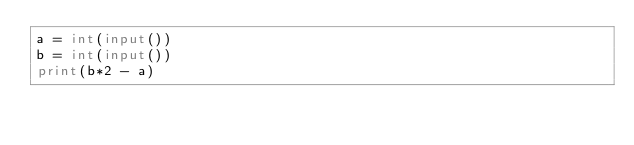Convert code to text. <code><loc_0><loc_0><loc_500><loc_500><_Python_>a = int(input())
b = int(input())
print(b*2 - a)
</code> 